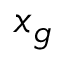<formula> <loc_0><loc_0><loc_500><loc_500>x _ { g }</formula> 